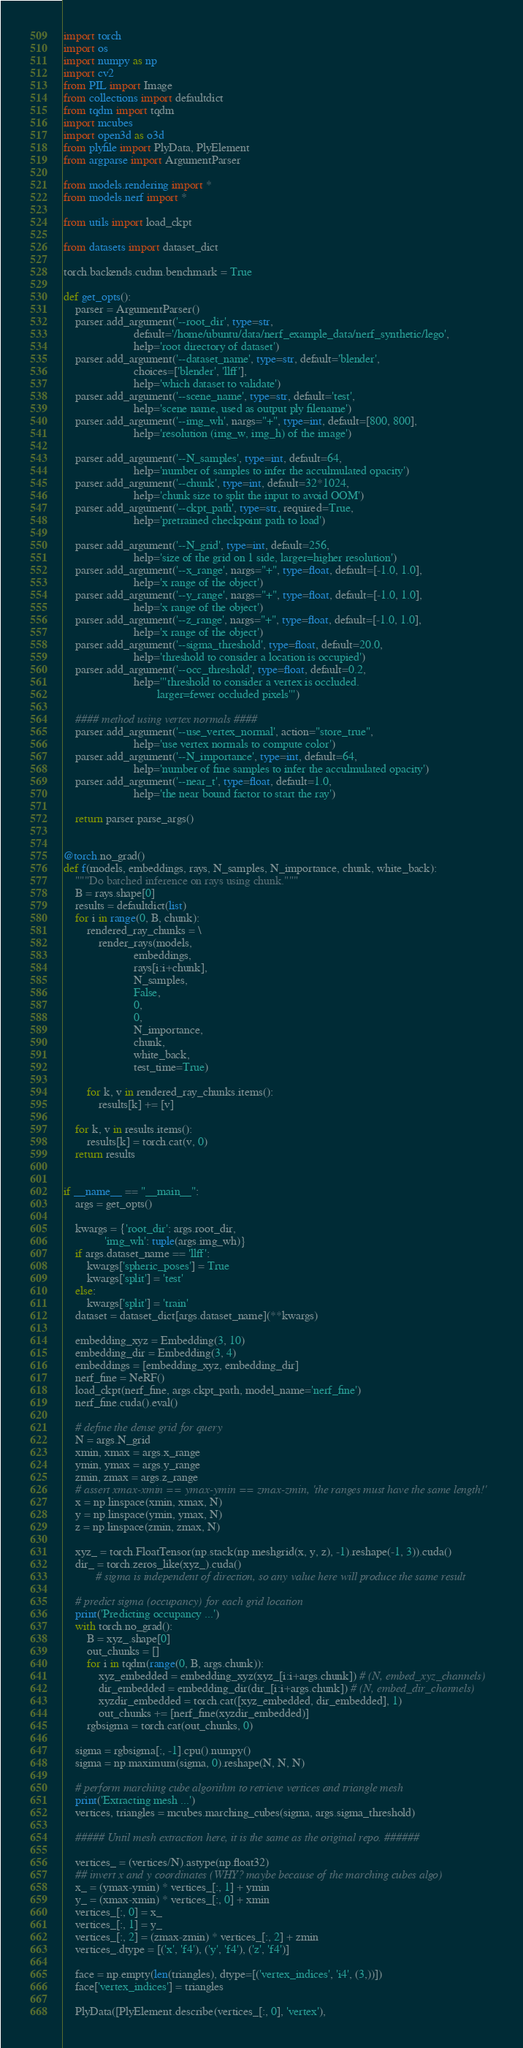<code> <loc_0><loc_0><loc_500><loc_500><_Python_>import torch
import os
import numpy as np
import cv2
from PIL import Image
from collections import defaultdict
from tqdm import tqdm
import mcubes
import open3d as o3d
from plyfile import PlyData, PlyElement
from argparse import ArgumentParser

from models.rendering import *
from models.nerf import *

from utils import load_ckpt

from datasets import dataset_dict

torch.backends.cudnn.benchmark = True

def get_opts():
    parser = ArgumentParser()
    parser.add_argument('--root_dir', type=str,
                        default='/home/ubuntu/data/nerf_example_data/nerf_synthetic/lego',
                        help='root directory of dataset')
    parser.add_argument('--dataset_name', type=str, default='blender',
                        choices=['blender', 'llff'],
                        help='which dataset to validate')
    parser.add_argument('--scene_name', type=str, default='test',
                        help='scene name, used as output ply filename')
    parser.add_argument('--img_wh', nargs="+", type=int, default=[800, 800],
                        help='resolution (img_w, img_h) of the image')

    parser.add_argument('--N_samples', type=int, default=64,
                        help='number of samples to infer the acculmulated opacity')
    parser.add_argument('--chunk', type=int, default=32*1024,
                        help='chunk size to split the input to avoid OOM')
    parser.add_argument('--ckpt_path', type=str, required=True,
                        help='pretrained checkpoint path to load')

    parser.add_argument('--N_grid', type=int, default=256,
                        help='size of the grid on 1 side, larger=higher resolution')
    parser.add_argument('--x_range', nargs="+", type=float, default=[-1.0, 1.0],
                        help='x range of the object')
    parser.add_argument('--y_range', nargs="+", type=float, default=[-1.0, 1.0],
                        help='x range of the object')
    parser.add_argument('--z_range', nargs="+", type=float, default=[-1.0, 1.0],
                        help='x range of the object')
    parser.add_argument('--sigma_threshold', type=float, default=20.0,
                        help='threshold to consider a location is occupied')
    parser.add_argument('--occ_threshold', type=float, default=0.2,
                        help='''threshold to consider a vertex is occluded.
                                larger=fewer occluded pixels''')

    #### method using vertex normals ####
    parser.add_argument('--use_vertex_normal', action="store_true",
                        help='use vertex normals to compute color')
    parser.add_argument('--N_importance', type=int, default=64,
                        help='number of fine samples to infer the acculmulated opacity')
    parser.add_argument('--near_t', type=float, default=1.0,
                        help='the near bound factor to start the ray')

    return parser.parse_args()


@torch.no_grad()
def f(models, embeddings, rays, N_samples, N_importance, chunk, white_back):
    """Do batched inference on rays using chunk."""
    B = rays.shape[0]
    results = defaultdict(list)
    for i in range(0, B, chunk):
        rendered_ray_chunks = \
            render_rays(models,
                        embeddings,
                        rays[i:i+chunk],
                        N_samples,
                        False,
                        0,
                        0,
                        N_importance,
                        chunk,
                        white_back,
                        test_time=True)

        for k, v in rendered_ray_chunks.items():
            results[k] += [v]

    for k, v in results.items():
        results[k] = torch.cat(v, 0)
    return results


if __name__ == "__main__":
    args = get_opts()

    kwargs = {'root_dir': args.root_dir,
              'img_wh': tuple(args.img_wh)}
    if args.dataset_name == 'llff':
        kwargs['spheric_poses'] = True
        kwargs['split'] = 'test'
    else:
        kwargs['split'] = 'train'
    dataset = dataset_dict[args.dataset_name](**kwargs)

    embedding_xyz = Embedding(3, 10)
    embedding_dir = Embedding(3, 4)
    embeddings = [embedding_xyz, embedding_dir]
    nerf_fine = NeRF()
    load_ckpt(nerf_fine, args.ckpt_path, model_name='nerf_fine')
    nerf_fine.cuda().eval()

    # define the dense grid for query
    N = args.N_grid
    xmin, xmax = args.x_range
    ymin, ymax = args.y_range
    zmin, zmax = args.z_range
    # assert xmax-xmin == ymax-ymin == zmax-zmin, 'the ranges must have the same length!'
    x = np.linspace(xmin, xmax, N)
    y = np.linspace(ymin, ymax, N)
    z = np.linspace(zmin, zmax, N)

    xyz_ = torch.FloatTensor(np.stack(np.meshgrid(x, y, z), -1).reshape(-1, 3)).cuda()
    dir_ = torch.zeros_like(xyz_).cuda()
           # sigma is independent of direction, so any value here will produce the same result

    # predict sigma (occupancy) for each grid location
    print('Predicting occupancy ...')
    with torch.no_grad():
        B = xyz_.shape[0]
        out_chunks = []
        for i in tqdm(range(0, B, args.chunk)):
            xyz_embedded = embedding_xyz(xyz_[i:i+args.chunk]) # (N, embed_xyz_channels)
            dir_embedded = embedding_dir(dir_[i:i+args.chunk]) # (N, embed_dir_channels)
            xyzdir_embedded = torch.cat([xyz_embedded, dir_embedded], 1)
            out_chunks += [nerf_fine(xyzdir_embedded)]
        rgbsigma = torch.cat(out_chunks, 0)

    sigma = rgbsigma[:, -1].cpu().numpy()
    sigma = np.maximum(sigma, 0).reshape(N, N, N)

    # perform marching cube algorithm to retrieve vertices and triangle mesh
    print('Extracting mesh ...')
    vertices, triangles = mcubes.marching_cubes(sigma, args.sigma_threshold)

    ##### Until mesh extraction here, it is the same as the original repo. ######

    vertices_ = (vertices/N).astype(np.float32)
    ## invert x and y coordinates (WHY? maybe because of the marching cubes algo)
    x_ = (ymax-ymin) * vertices_[:, 1] + ymin
    y_ = (xmax-xmin) * vertices_[:, 0] + xmin
    vertices_[:, 0] = x_
    vertices_[:, 1] = y_
    vertices_[:, 2] = (zmax-zmin) * vertices_[:, 2] + zmin
    vertices_.dtype = [('x', 'f4'), ('y', 'f4'), ('z', 'f4')]

    face = np.empty(len(triangles), dtype=[('vertex_indices', 'i4', (3,))])
    face['vertex_indices'] = triangles

    PlyData([PlyElement.describe(vertices_[:, 0], 'vertex'), </code> 